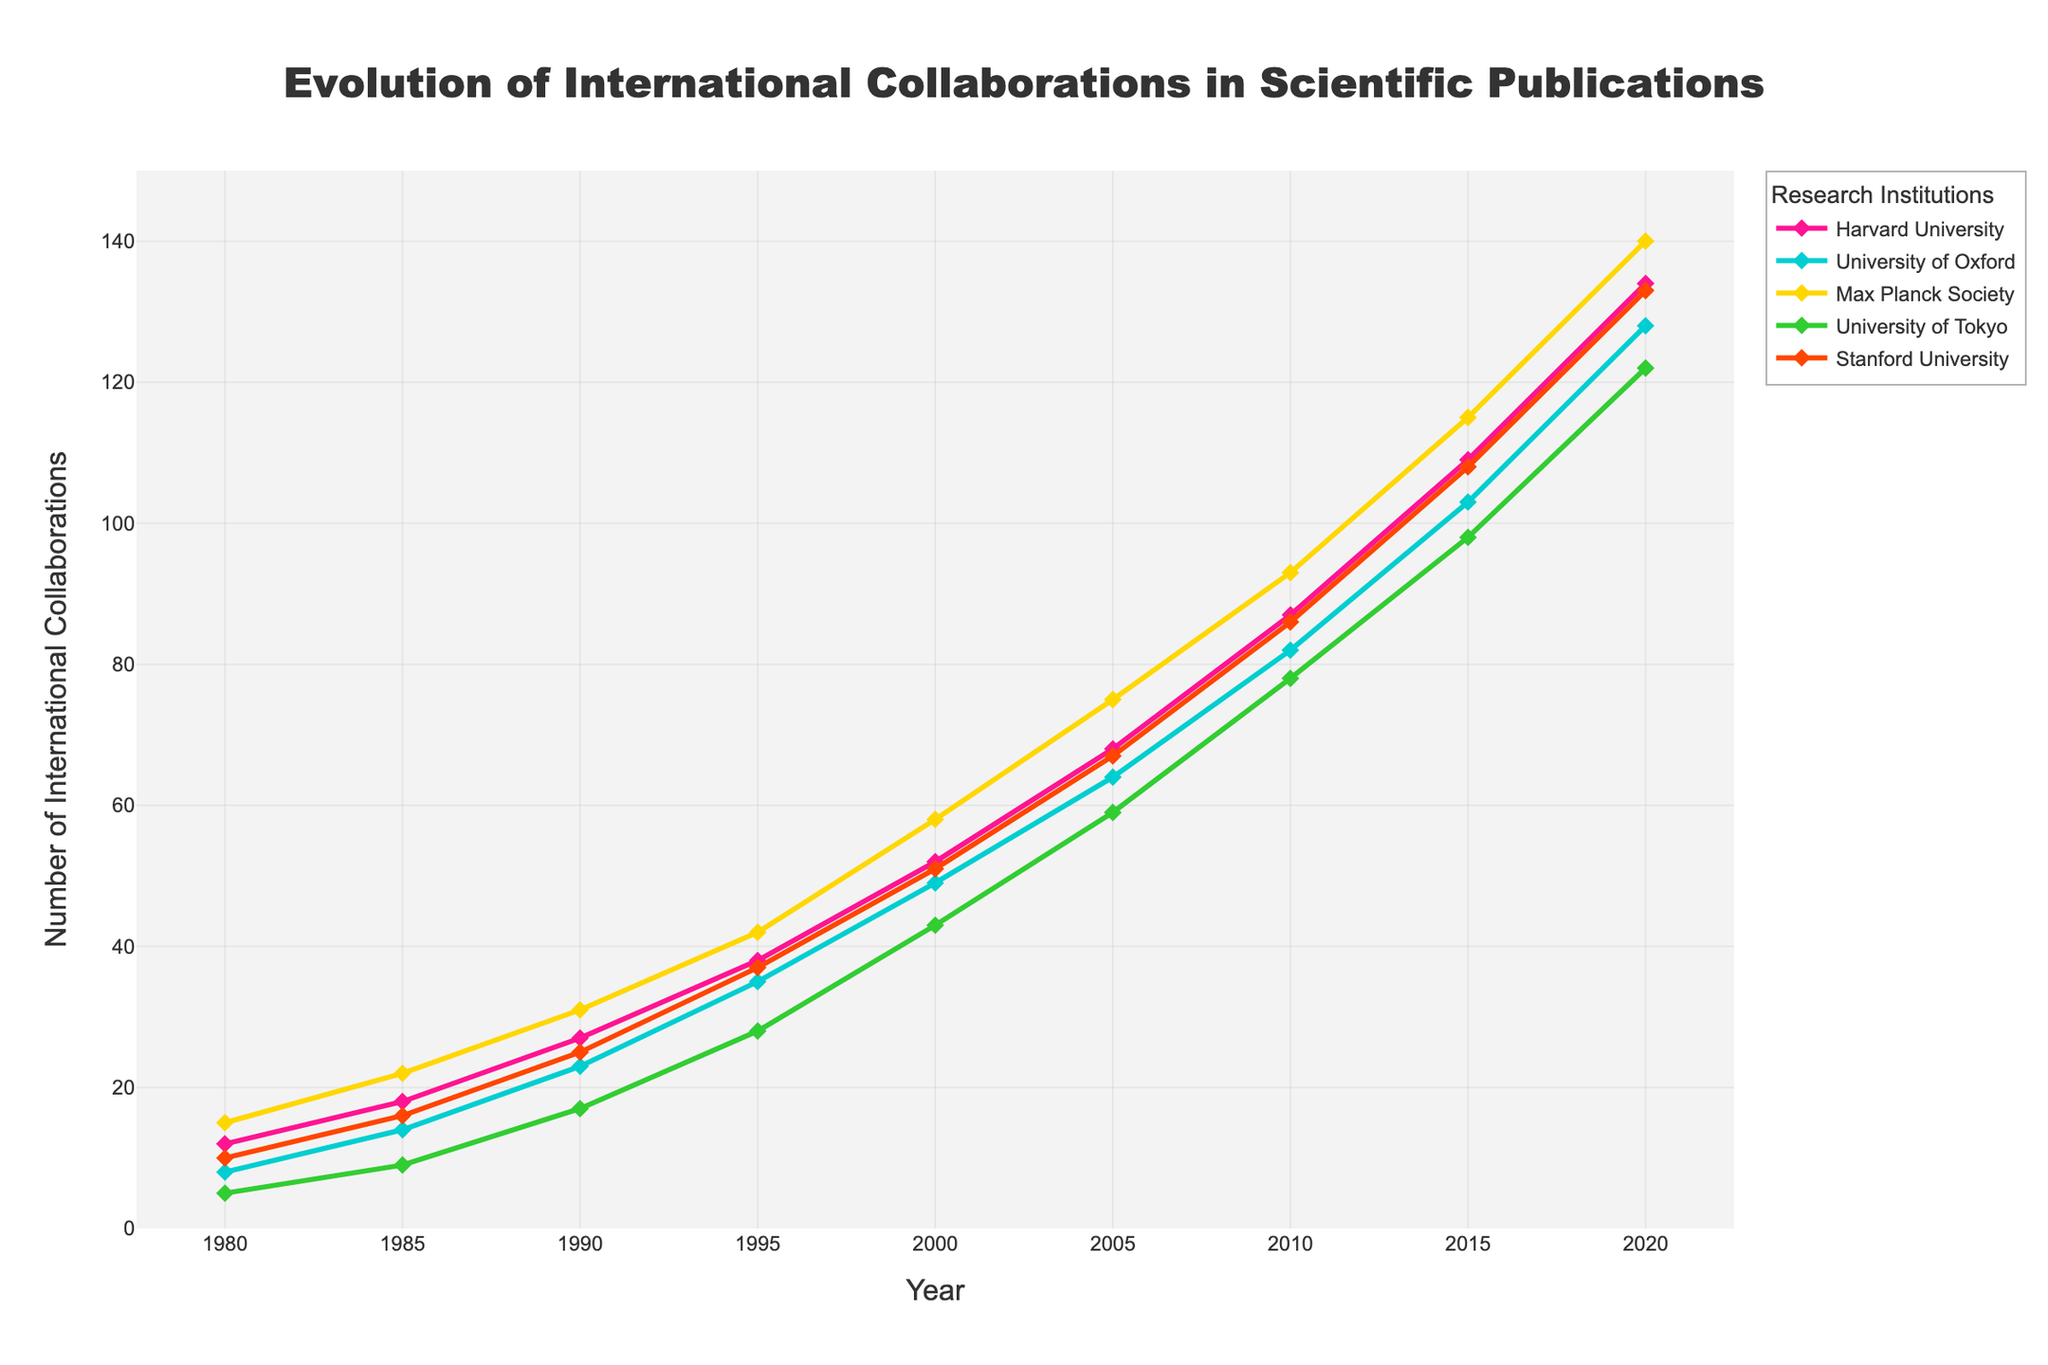What is the trend in the number of international collaborations for Harvard University from 1980 to 2020? The plot shows a continuous upward trend in the number of international collaborations for Harvard University from 1980 to 2020. Starting at 12 in 1980 and rising to 134 in 2020, the number of collaborations increases consistently across the years.
Answer: Continuous upward trend Which institution had the highest number of international collaborations in 2020? By looking at the endpoint of each line in 2020, we can see that Harvard University had the highest number of international collaborations, with a count of 134.
Answer: Harvard University By how much did the international collaborations increase at the University of Tokyo between 1990 and 2020? In 1990, University of Tokyo had 17 collaborations, which increased to 122 by 2020. The increase is calculated as 122 - 17 = 105.
Answer: 105 collaborations How do the trends for the University of Oxford and Stanford University compare from 1980 to 2020? Both universities show upward trends in their international collaborations, but the University of Oxford consistently has higher numbers than Stanford University from 1985 onwards. In 1980, Oxford had 8, while Stanford had 10. By 2020, Oxford's count was 128, while Stanford's was 133, making Oxford's growth rate slightly slower but maintaining higher numbers for most of the period.
Answer: Oxford generally higher, slower growth What is the difference in the number of international collaborations between Harvard University and Max Planck Society in 2010? In 2010, Harvard University had 87 collaborations, while Max Planck Society had 93. The difference is 93 - 87 = 6.
Answer: 6 collaborations Which institution showed the most significant increase in international collaborations from 2000 to 2010? By looking at the differences between 2000 and 2010 for each institution, Harvard University increased from 52 to 87 (35), University of Oxford from 49 to 82 (33), Max Planck Society from 58 to 93 (35), University of Tokyo from 43 to 78 (35), and Stanford University from 51 to 86 (35). All institutions show similar increases of around 35 collaborations.
Answer: Similar increases (around 35) What can be inferred about the collaboration growth rate of Max Planck Society compared to the University of Tokyo between 1980 and 2020? Max Planck Society starts at 15 in 1980 and grows to 140 in 2020, while University of Tokyo starts at 5 in 1980 and grows to 122 in 2020. Max Planck's growth rate appears to be higher.
Answer: Max Planck Society has a higher growth rate In which decade did Stanford University see the highest growth in international collaborations? Looking at the differences between decades, Stanford’s growth is as follows: 1980-85 (+6), 1985-90 (+9), 1990-95 (+12), 1995-2000 (+14), 2000-2005 (+16), 2005-2010 (+19), 2010-2015 (+22), and 2015-2020 (+25). The highest growth occurred between 2015 and 2020 with an increase of 25 collaborations.
Answer: 2015-2020 Which institution consistently has the lowest number of international collaborations throughout the period? Examining the lines visually, the University of Tokyo consistently has the lowest number of international collaborations from 1980 to 2020.
Answer: University of Tokyo 